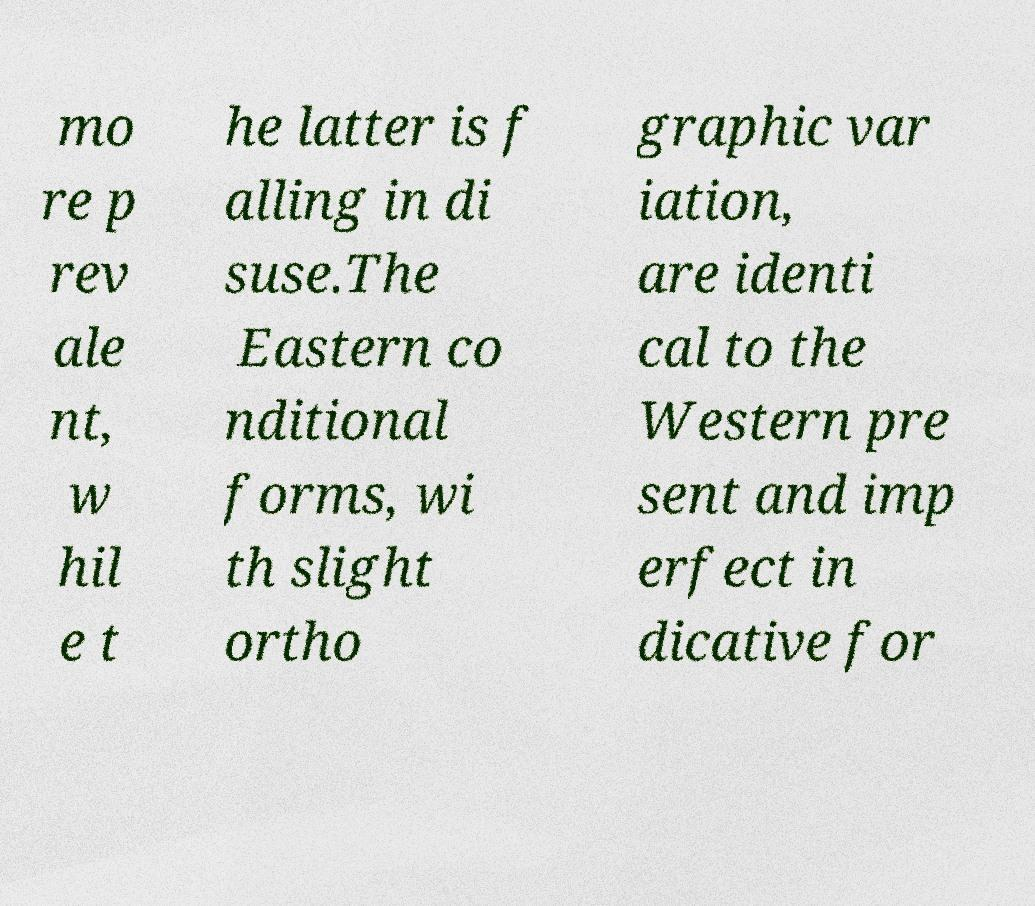What messages or text are displayed in this image? I need them in a readable, typed format. mo re p rev ale nt, w hil e t he latter is f alling in di suse.The Eastern co nditional forms, wi th slight ortho graphic var iation, are identi cal to the Western pre sent and imp erfect in dicative for 